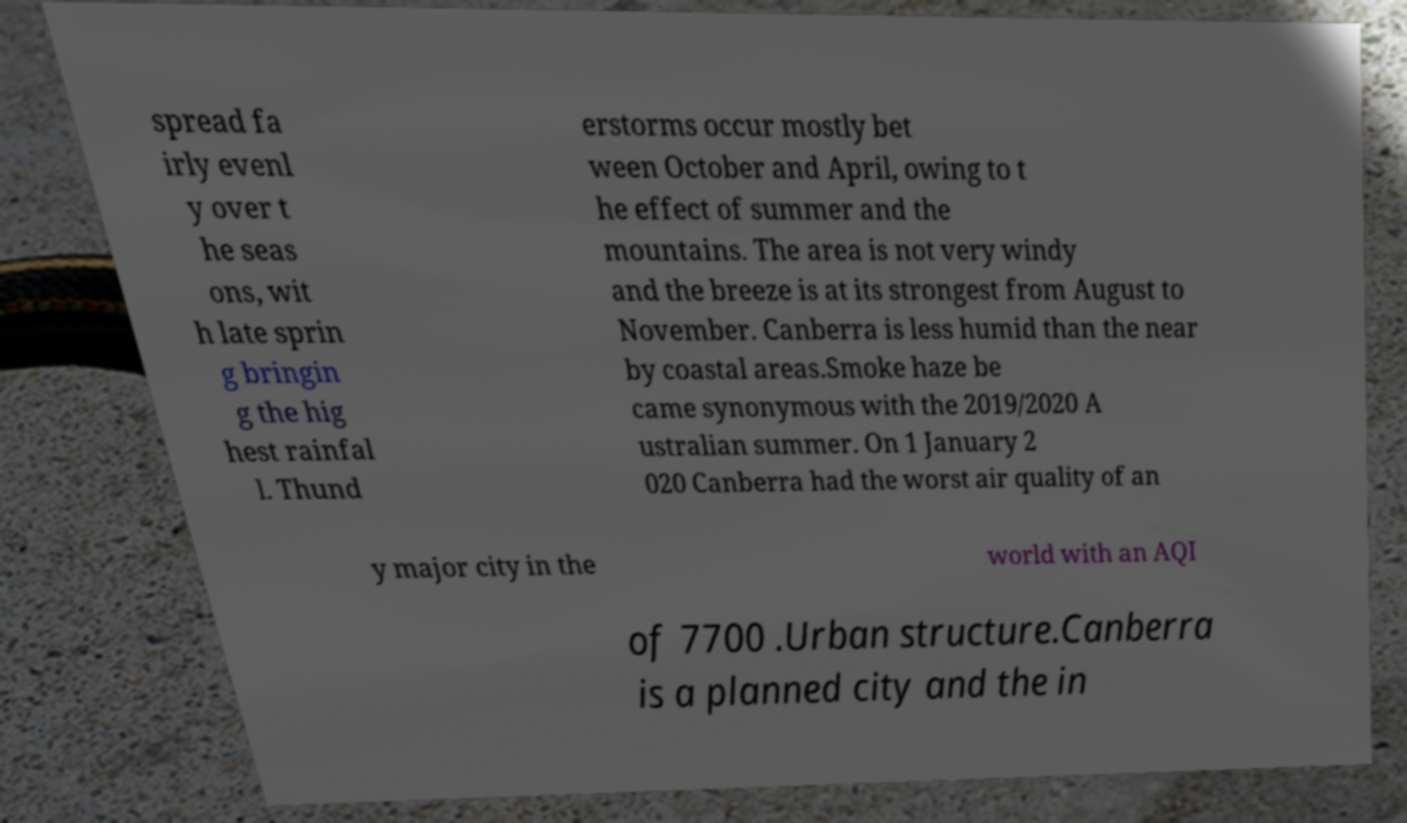Can you read and provide the text displayed in the image?This photo seems to have some interesting text. Can you extract and type it out for me? spread fa irly evenl y over t he seas ons, wit h late sprin g bringin g the hig hest rainfal l. Thund erstorms occur mostly bet ween October and April, owing to t he effect of summer and the mountains. The area is not very windy and the breeze is at its strongest from August to November. Canberra is less humid than the near by coastal areas.Smoke haze be came synonymous with the 2019/2020 A ustralian summer. On 1 January 2 020 Canberra had the worst air quality of an y major city in the world with an AQI of 7700 .Urban structure.Canberra is a planned city and the in 